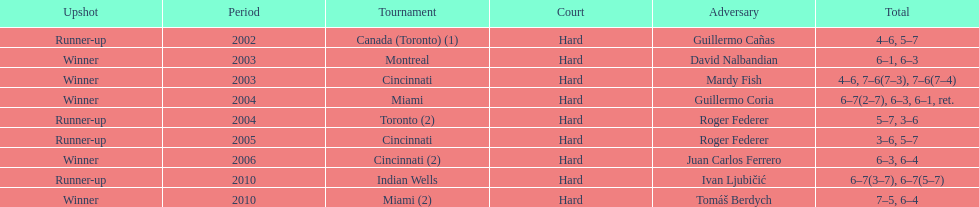How many times has he been runner-up? 4. 